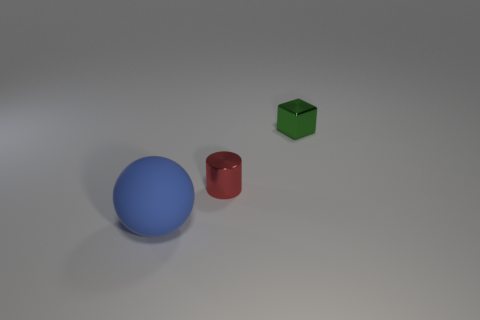Is there any other thing that has the same material as the ball?
Your answer should be very brief. No. How many red things are tiny shiny blocks or small metal things?
Your answer should be very brief. 1. Are there the same number of tiny blocks that are in front of the green shiny object and big gray metal things?
Ensure brevity in your answer.  Yes. Are there any other things that are the same size as the blue matte sphere?
Ensure brevity in your answer.  No. What number of tiny green cubes are there?
Your response must be concise. 1. Are there any small things made of the same material as the ball?
Your response must be concise. No. There is a shiny thing that is to the left of the green thing; does it have the same size as the thing in front of the tiny red metal thing?
Make the answer very short. No. What is the size of the metallic object on the left side of the small green block?
Provide a succinct answer. Small. Are there any tiny metallic things that have the same color as the sphere?
Provide a short and direct response. No. Is there a large blue thing to the left of the blue matte thing that is in front of the cylinder?
Your answer should be very brief. No. 